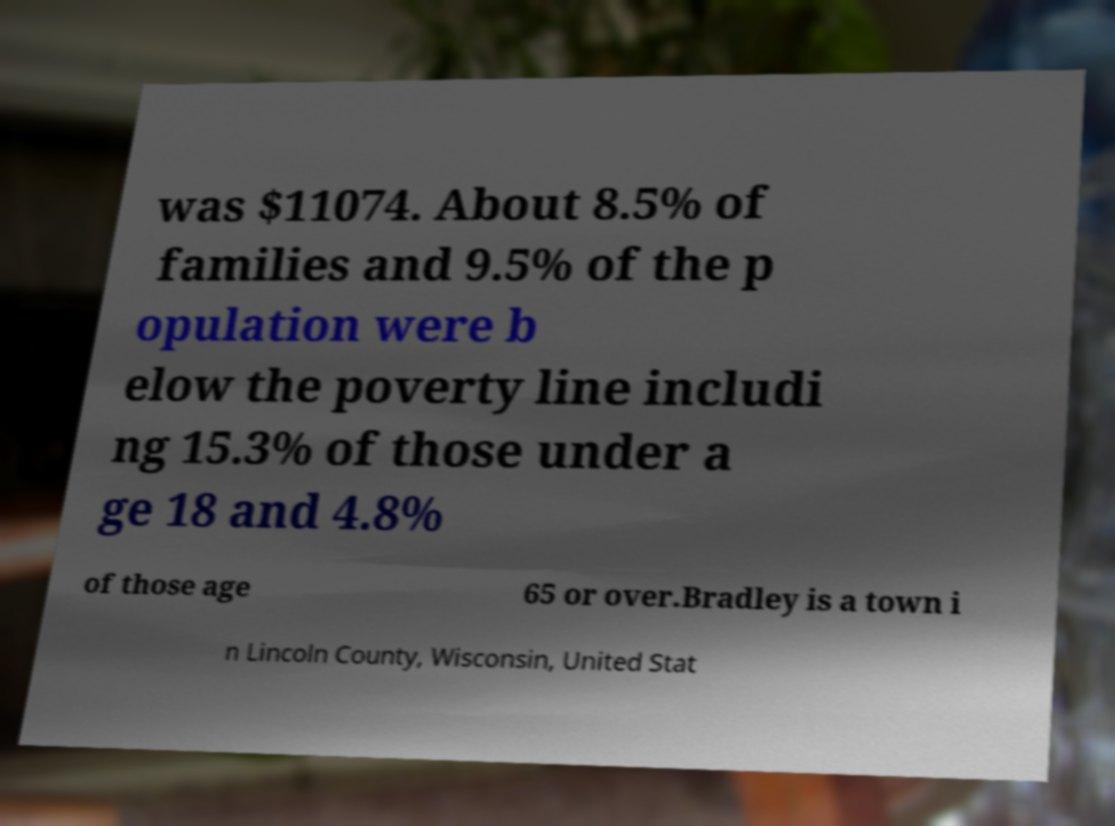Can you accurately transcribe the text from the provided image for me? was $11074. About 8.5% of families and 9.5% of the p opulation were b elow the poverty line includi ng 15.3% of those under a ge 18 and 4.8% of those age 65 or over.Bradley is a town i n Lincoln County, Wisconsin, United Stat 